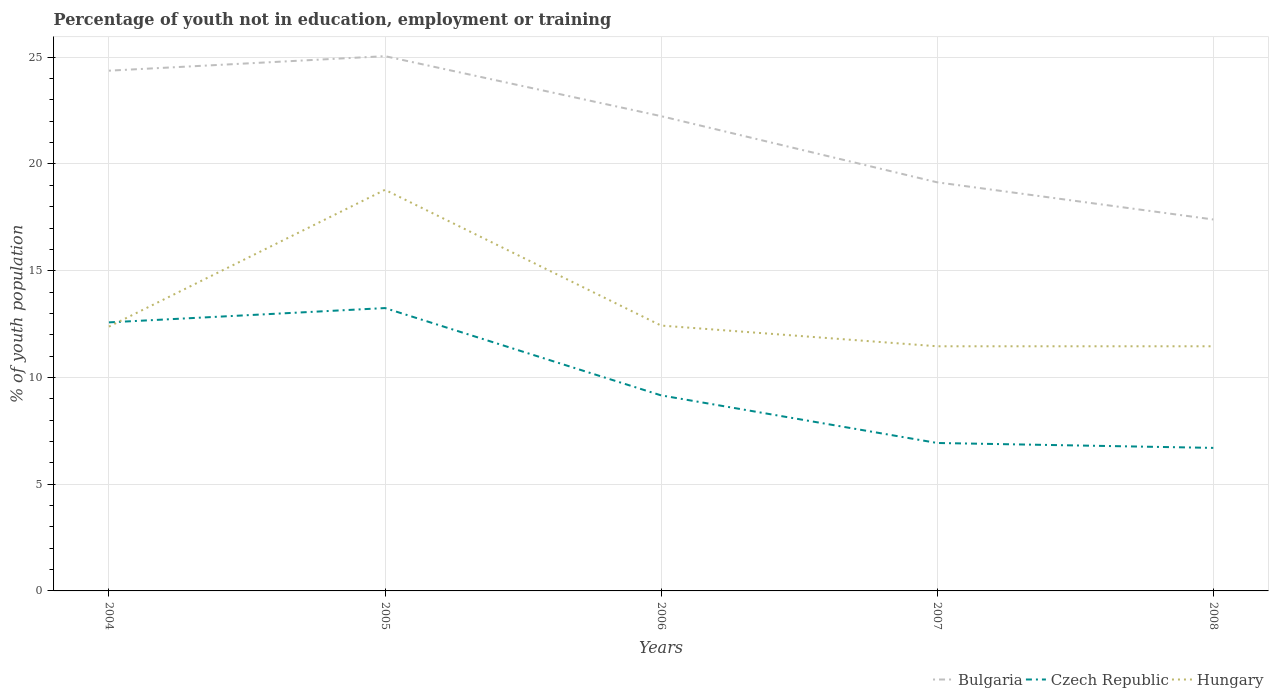How many different coloured lines are there?
Your answer should be compact. 3. Across all years, what is the maximum percentage of unemployed youth population in in Czech Republic?
Your answer should be very brief. 6.7. What is the total percentage of unemployed youth population in in Hungary in the graph?
Give a very brief answer. -6.41. What is the difference between the highest and the second highest percentage of unemployed youth population in in Czech Republic?
Your answer should be very brief. 6.55. What is the difference between the highest and the lowest percentage of unemployed youth population in in Hungary?
Ensure brevity in your answer.  1. How many lines are there?
Offer a very short reply. 3. Does the graph contain grids?
Your answer should be compact. Yes. Where does the legend appear in the graph?
Keep it short and to the point. Bottom right. How many legend labels are there?
Provide a succinct answer. 3. How are the legend labels stacked?
Provide a short and direct response. Horizontal. What is the title of the graph?
Your answer should be compact. Percentage of youth not in education, employment or training. Does "Sweden" appear as one of the legend labels in the graph?
Your answer should be compact. No. What is the label or title of the X-axis?
Keep it short and to the point. Years. What is the label or title of the Y-axis?
Provide a succinct answer. % of youth population. What is the % of youth population of Bulgaria in 2004?
Make the answer very short. 24.37. What is the % of youth population in Czech Republic in 2004?
Give a very brief answer. 12.58. What is the % of youth population of Hungary in 2004?
Your response must be concise. 12.38. What is the % of youth population in Bulgaria in 2005?
Your answer should be compact. 25.05. What is the % of youth population of Czech Republic in 2005?
Provide a short and direct response. 13.25. What is the % of youth population of Hungary in 2005?
Your response must be concise. 18.79. What is the % of youth population in Bulgaria in 2006?
Make the answer very short. 22.24. What is the % of youth population in Czech Republic in 2006?
Ensure brevity in your answer.  9.16. What is the % of youth population of Hungary in 2006?
Your answer should be very brief. 12.43. What is the % of youth population in Bulgaria in 2007?
Your response must be concise. 19.14. What is the % of youth population of Czech Republic in 2007?
Your answer should be compact. 6.93. What is the % of youth population of Hungary in 2007?
Keep it short and to the point. 11.46. What is the % of youth population of Bulgaria in 2008?
Provide a succinct answer. 17.4. What is the % of youth population of Czech Republic in 2008?
Your answer should be compact. 6.7. What is the % of youth population in Hungary in 2008?
Offer a terse response. 11.46. Across all years, what is the maximum % of youth population of Bulgaria?
Provide a short and direct response. 25.05. Across all years, what is the maximum % of youth population in Czech Republic?
Give a very brief answer. 13.25. Across all years, what is the maximum % of youth population of Hungary?
Keep it short and to the point. 18.79. Across all years, what is the minimum % of youth population in Bulgaria?
Ensure brevity in your answer.  17.4. Across all years, what is the minimum % of youth population of Czech Republic?
Offer a terse response. 6.7. Across all years, what is the minimum % of youth population of Hungary?
Provide a short and direct response. 11.46. What is the total % of youth population in Bulgaria in the graph?
Ensure brevity in your answer.  108.2. What is the total % of youth population in Czech Republic in the graph?
Keep it short and to the point. 48.62. What is the total % of youth population of Hungary in the graph?
Your answer should be very brief. 66.52. What is the difference between the % of youth population of Bulgaria in 2004 and that in 2005?
Offer a terse response. -0.68. What is the difference between the % of youth population in Czech Republic in 2004 and that in 2005?
Your answer should be compact. -0.67. What is the difference between the % of youth population in Hungary in 2004 and that in 2005?
Ensure brevity in your answer.  -6.41. What is the difference between the % of youth population in Bulgaria in 2004 and that in 2006?
Your answer should be very brief. 2.13. What is the difference between the % of youth population of Czech Republic in 2004 and that in 2006?
Provide a succinct answer. 3.42. What is the difference between the % of youth population of Hungary in 2004 and that in 2006?
Ensure brevity in your answer.  -0.05. What is the difference between the % of youth population in Bulgaria in 2004 and that in 2007?
Your answer should be very brief. 5.23. What is the difference between the % of youth population in Czech Republic in 2004 and that in 2007?
Provide a succinct answer. 5.65. What is the difference between the % of youth population of Bulgaria in 2004 and that in 2008?
Provide a short and direct response. 6.97. What is the difference between the % of youth population of Czech Republic in 2004 and that in 2008?
Offer a very short reply. 5.88. What is the difference between the % of youth population in Hungary in 2004 and that in 2008?
Provide a succinct answer. 0.92. What is the difference between the % of youth population of Bulgaria in 2005 and that in 2006?
Offer a very short reply. 2.81. What is the difference between the % of youth population of Czech Republic in 2005 and that in 2006?
Your response must be concise. 4.09. What is the difference between the % of youth population in Hungary in 2005 and that in 2006?
Give a very brief answer. 6.36. What is the difference between the % of youth population in Bulgaria in 2005 and that in 2007?
Make the answer very short. 5.91. What is the difference between the % of youth population of Czech Republic in 2005 and that in 2007?
Offer a very short reply. 6.32. What is the difference between the % of youth population of Hungary in 2005 and that in 2007?
Provide a short and direct response. 7.33. What is the difference between the % of youth population of Bulgaria in 2005 and that in 2008?
Give a very brief answer. 7.65. What is the difference between the % of youth population in Czech Republic in 2005 and that in 2008?
Your response must be concise. 6.55. What is the difference between the % of youth population of Hungary in 2005 and that in 2008?
Keep it short and to the point. 7.33. What is the difference between the % of youth population in Bulgaria in 2006 and that in 2007?
Make the answer very short. 3.1. What is the difference between the % of youth population of Czech Republic in 2006 and that in 2007?
Provide a short and direct response. 2.23. What is the difference between the % of youth population of Hungary in 2006 and that in 2007?
Your answer should be very brief. 0.97. What is the difference between the % of youth population of Bulgaria in 2006 and that in 2008?
Your response must be concise. 4.84. What is the difference between the % of youth population of Czech Republic in 2006 and that in 2008?
Your answer should be compact. 2.46. What is the difference between the % of youth population in Bulgaria in 2007 and that in 2008?
Keep it short and to the point. 1.74. What is the difference between the % of youth population in Czech Republic in 2007 and that in 2008?
Keep it short and to the point. 0.23. What is the difference between the % of youth population of Hungary in 2007 and that in 2008?
Offer a very short reply. 0. What is the difference between the % of youth population in Bulgaria in 2004 and the % of youth population in Czech Republic in 2005?
Ensure brevity in your answer.  11.12. What is the difference between the % of youth population in Bulgaria in 2004 and the % of youth population in Hungary in 2005?
Offer a terse response. 5.58. What is the difference between the % of youth population in Czech Republic in 2004 and the % of youth population in Hungary in 2005?
Provide a succinct answer. -6.21. What is the difference between the % of youth population in Bulgaria in 2004 and the % of youth population in Czech Republic in 2006?
Keep it short and to the point. 15.21. What is the difference between the % of youth population in Bulgaria in 2004 and the % of youth population in Hungary in 2006?
Make the answer very short. 11.94. What is the difference between the % of youth population of Czech Republic in 2004 and the % of youth population of Hungary in 2006?
Give a very brief answer. 0.15. What is the difference between the % of youth population in Bulgaria in 2004 and the % of youth population in Czech Republic in 2007?
Provide a succinct answer. 17.44. What is the difference between the % of youth population of Bulgaria in 2004 and the % of youth population of Hungary in 2007?
Give a very brief answer. 12.91. What is the difference between the % of youth population of Czech Republic in 2004 and the % of youth population of Hungary in 2007?
Your response must be concise. 1.12. What is the difference between the % of youth population in Bulgaria in 2004 and the % of youth population in Czech Republic in 2008?
Your answer should be very brief. 17.67. What is the difference between the % of youth population in Bulgaria in 2004 and the % of youth population in Hungary in 2008?
Your response must be concise. 12.91. What is the difference between the % of youth population in Czech Republic in 2004 and the % of youth population in Hungary in 2008?
Provide a short and direct response. 1.12. What is the difference between the % of youth population of Bulgaria in 2005 and the % of youth population of Czech Republic in 2006?
Offer a terse response. 15.89. What is the difference between the % of youth population of Bulgaria in 2005 and the % of youth population of Hungary in 2006?
Offer a terse response. 12.62. What is the difference between the % of youth population in Czech Republic in 2005 and the % of youth population in Hungary in 2006?
Offer a terse response. 0.82. What is the difference between the % of youth population of Bulgaria in 2005 and the % of youth population of Czech Republic in 2007?
Provide a short and direct response. 18.12. What is the difference between the % of youth population of Bulgaria in 2005 and the % of youth population of Hungary in 2007?
Offer a very short reply. 13.59. What is the difference between the % of youth population in Czech Republic in 2005 and the % of youth population in Hungary in 2007?
Your answer should be compact. 1.79. What is the difference between the % of youth population of Bulgaria in 2005 and the % of youth population of Czech Republic in 2008?
Provide a short and direct response. 18.35. What is the difference between the % of youth population of Bulgaria in 2005 and the % of youth population of Hungary in 2008?
Your answer should be very brief. 13.59. What is the difference between the % of youth population of Czech Republic in 2005 and the % of youth population of Hungary in 2008?
Your answer should be compact. 1.79. What is the difference between the % of youth population in Bulgaria in 2006 and the % of youth population in Czech Republic in 2007?
Offer a very short reply. 15.31. What is the difference between the % of youth population of Bulgaria in 2006 and the % of youth population of Hungary in 2007?
Your answer should be compact. 10.78. What is the difference between the % of youth population in Czech Republic in 2006 and the % of youth population in Hungary in 2007?
Ensure brevity in your answer.  -2.3. What is the difference between the % of youth population in Bulgaria in 2006 and the % of youth population in Czech Republic in 2008?
Give a very brief answer. 15.54. What is the difference between the % of youth population of Bulgaria in 2006 and the % of youth population of Hungary in 2008?
Keep it short and to the point. 10.78. What is the difference between the % of youth population in Czech Republic in 2006 and the % of youth population in Hungary in 2008?
Offer a very short reply. -2.3. What is the difference between the % of youth population in Bulgaria in 2007 and the % of youth population in Czech Republic in 2008?
Offer a terse response. 12.44. What is the difference between the % of youth population of Bulgaria in 2007 and the % of youth population of Hungary in 2008?
Give a very brief answer. 7.68. What is the difference between the % of youth population in Czech Republic in 2007 and the % of youth population in Hungary in 2008?
Provide a short and direct response. -4.53. What is the average % of youth population in Bulgaria per year?
Make the answer very short. 21.64. What is the average % of youth population of Czech Republic per year?
Ensure brevity in your answer.  9.72. What is the average % of youth population in Hungary per year?
Offer a terse response. 13.3. In the year 2004, what is the difference between the % of youth population in Bulgaria and % of youth population in Czech Republic?
Provide a short and direct response. 11.79. In the year 2004, what is the difference between the % of youth population in Bulgaria and % of youth population in Hungary?
Give a very brief answer. 11.99. In the year 2005, what is the difference between the % of youth population of Bulgaria and % of youth population of Czech Republic?
Give a very brief answer. 11.8. In the year 2005, what is the difference between the % of youth population in Bulgaria and % of youth population in Hungary?
Offer a very short reply. 6.26. In the year 2005, what is the difference between the % of youth population in Czech Republic and % of youth population in Hungary?
Offer a very short reply. -5.54. In the year 2006, what is the difference between the % of youth population in Bulgaria and % of youth population in Czech Republic?
Offer a terse response. 13.08. In the year 2006, what is the difference between the % of youth population in Bulgaria and % of youth population in Hungary?
Provide a succinct answer. 9.81. In the year 2006, what is the difference between the % of youth population in Czech Republic and % of youth population in Hungary?
Make the answer very short. -3.27. In the year 2007, what is the difference between the % of youth population in Bulgaria and % of youth population in Czech Republic?
Make the answer very short. 12.21. In the year 2007, what is the difference between the % of youth population in Bulgaria and % of youth population in Hungary?
Your answer should be compact. 7.68. In the year 2007, what is the difference between the % of youth population in Czech Republic and % of youth population in Hungary?
Make the answer very short. -4.53. In the year 2008, what is the difference between the % of youth population in Bulgaria and % of youth population in Hungary?
Your answer should be very brief. 5.94. In the year 2008, what is the difference between the % of youth population of Czech Republic and % of youth population of Hungary?
Give a very brief answer. -4.76. What is the ratio of the % of youth population of Bulgaria in 2004 to that in 2005?
Keep it short and to the point. 0.97. What is the ratio of the % of youth population in Czech Republic in 2004 to that in 2005?
Provide a succinct answer. 0.95. What is the ratio of the % of youth population of Hungary in 2004 to that in 2005?
Make the answer very short. 0.66. What is the ratio of the % of youth population in Bulgaria in 2004 to that in 2006?
Your answer should be very brief. 1.1. What is the ratio of the % of youth population in Czech Republic in 2004 to that in 2006?
Provide a short and direct response. 1.37. What is the ratio of the % of youth population of Hungary in 2004 to that in 2006?
Your answer should be very brief. 1. What is the ratio of the % of youth population of Bulgaria in 2004 to that in 2007?
Make the answer very short. 1.27. What is the ratio of the % of youth population in Czech Republic in 2004 to that in 2007?
Provide a succinct answer. 1.82. What is the ratio of the % of youth population of Hungary in 2004 to that in 2007?
Provide a succinct answer. 1.08. What is the ratio of the % of youth population of Bulgaria in 2004 to that in 2008?
Your response must be concise. 1.4. What is the ratio of the % of youth population in Czech Republic in 2004 to that in 2008?
Offer a very short reply. 1.88. What is the ratio of the % of youth population in Hungary in 2004 to that in 2008?
Provide a succinct answer. 1.08. What is the ratio of the % of youth population in Bulgaria in 2005 to that in 2006?
Your answer should be very brief. 1.13. What is the ratio of the % of youth population in Czech Republic in 2005 to that in 2006?
Provide a short and direct response. 1.45. What is the ratio of the % of youth population of Hungary in 2005 to that in 2006?
Provide a short and direct response. 1.51. What is the ratio of the % of youth population of Bulgaria in 2005 to that in 2007?
Your answer should be very brief. 1.31. What is the ratio of the % of youth population of Czech Republic in 2005 to that in 2007?
Your answer should be very brief. 1.91. What is the ratio of the % of youth population in Hungary in 2005 to that in 2007?
Provide a succinct answer. 1.64. What is the ratio of the % of youth population of Bulgaria in 2005 to that in 2008?
Provide a short and direct response. 1.44. What is the ratio of the % of youth population of Czech Republic in 2005 to that in 2008?
Provide a short and direct response. 1.98. What is the ratio of the % of youth population in Hungary in 2005 to that in 2008?
Ensure brevity in your answer.  1.64. What is the ratio of the % of youth population of Bulgaria in 2006 to that in 2007?
Ensure brevity in your answer.  1.16. What is the ratio of the % of youth population in Czech Republic in 2006 to that in 2007?
Provide a succinct answer. 1.32. What is the ratio of the % of youth population of Hungary in 2006 to that in 2007?
Your response must be concise. 1.08. What is the ratio of the % of youth population of Bulgaria in 2006 to that in 2008?
Provide a succinct answer. 1.28. What is the ratio of the % of youth population of Czech Republic in 2006 to that in 2008?
Offer a terse response. 1.37. What is the ratio of the % of youth population in Hungary in 2006 to that in 2008?
Ensure brevity in your answer.  1.08. What is the ratio of the % of youth population of Czech Republic in 2007 to that in 2008?
Offer a terse response. 1.03. What is the ratio of the % of youth population of Hungary in 2007 to that in 2008?
Provide a short and direct response. 1. What is the difference between the highest and the second highest % of youth population of Bulgaria?
Provide a succinct answer. 0.68. What is the difference between the highest and the second highest % of youth population of Czech Republic?
Offer a very short reply. 0.67. What is the difference between the highest and the second highest % of youth population in Hungary?
Your answer should be very brief. 6.36. What is the difference between the highest and the lowest % of youth population in Bulgaria?
Your answer should be compact. 7.65. What is the difference between the highest and the lowest % of youth population in Czech Republic?
Your answer should be compact. 6.55. What is the difference between the highest and the lowest % of youth population in Hungary?
Ensure brevity in your answer.  7.33. 